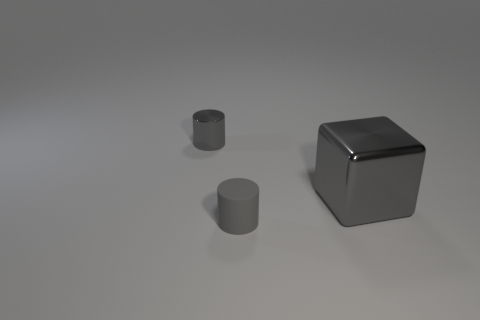How many other things are made of the same material as the gray cube? Based on the image, there are two other objects that appear to be made of the same or similar material as the gray cube, likely a metal or metallic-like substance given the sheen and reflections. 